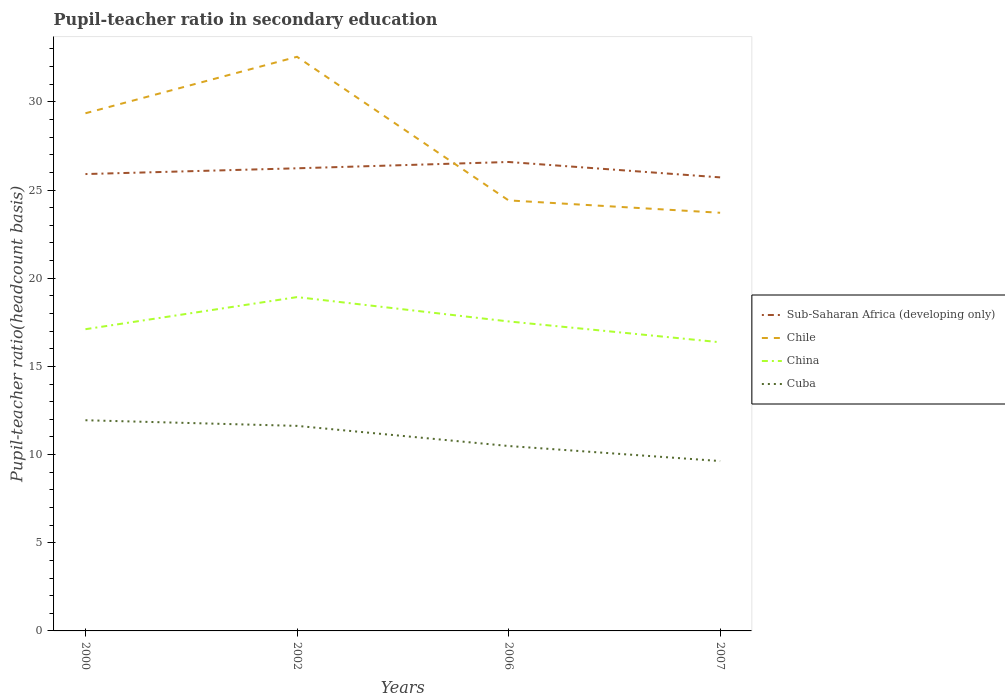Does the line corresponding to Sub-Saharan Africa (developing only) intersect with the line corresponding to China?
Your answer should be very brief. No. Across all years, what is the maximum pupil-teacher ratio in secondary education in China?
Keep it short and to the point. 16.37. In which year was the pupil-teacher ratio in secondary education in Sub-Saharan Africa (developing only) maximum?
Offer a terse response. 2007. What is the total pupil-teacher ratio in secondary education in Sub-Saharan Africa (developing only) in the graph?
Make the answer very short. -0.36. What is the difference between the highest and the second highest pupil-teacher ratio in secondary education in China?
Make the answer very short. 2.56. What is the difference between the highest and the lowest pupil-teacher ratio in secondary education in Chile?
Your answer should be compact. 2. Is the pupil-teacher ratio in secondary education in Chile strictly greater than the pupil-teacher ratio in secondary education in Sub-Saharan Africa (developing only) over the years?
Provide a short and direct response. No. Where does the legend appear in the graph?
Keep it short and to the point. Center right. How many legend labels are there?
Your response must be concise. 4. How are the legend labels stacked?
Your answer should be compact. Vertical. What is the title of the graph?
Make the answer very short. Pupil-teacher ratio in secondary education. Does "Mauritania" appear as one of the legend labels in the graph?
Offer a terse response. No. What is the label or title of the X-axis?
Your answer should be compact. Years. What is the label or title of the Y-axis?
Your response must be concise. Pupil-teacher ratio(headcount basis). What is the Pupil-teacher ratio(headcount basis) in Sub-Saharan Africa (developing only) in 2000?
Make the answer very short. 25.91. What is the Pupil-teacher ratio(headcount basis) of Chile in 2000?
Your answer should be compact. 29.35. What is the Pupil-teacher ratio(headcount basis) of China in 2000?
Offer a terse response. 17.11. What is the Pupil-teacher ratio(headcount basis) of Cuba in 2000?
Your answer should be compact. 11.95. What is the Pupil-teacher ratio(headcount basis) in Sub-Saharan Africa (developing only) in 2002?
Provide a succinct answer. 26.23. What is the Pupil-teacher ratio(headcount basis) of Chile in 2002?
Ensure brevity in your answer.  32.56. What is the Pupil-teacher ratio(headcount basis) of China in 2002?
Keep it short and to the point. 18.93. What is the Pupil-teacher ratio(headcount basis) in Cuba in 2002?
Keep it short and to the point. 11.63. What is the Pupil-teacher ratio(headcount basis) in Sub-Saharan Africa (developing only) in 2006?
Offer a terse response. 26.59. What is the Pupil-teacher ratio(headcount basis) in Chile in 2006?
Provide a short and direct response. 24.41. What is the Pupil-teacher ratio(headcount basis) of China in 2006?
Provide a succinct answer. 17.55. What is the Pupil-teacher ratio(headcount basis) of Cuba in 2006?
Provide a succinct answer. 10.49. What is the Pupil-teacher ratio(headcount basis) of Sub-Saharan Africa (developing only) in 2007?
Provide a short and direct response. 25.72. What is the Pupil-teacher ratio(headcount basis) in Chile in 2007?
Your answer should be compact. 23.71. What is the Pupil-teacher ratio(headcount basis) of China in 2007?
Keep it short and to the point. 16.37. What is the Pupil-teacher ratio(headcount basis) of Cuba in 2007?
Keep it short and to the point. 9.63. Across all years, what is the maximum Pupil-teacher ratio(headcount basis) of Sub-Saharan Africa (developing only)?
Keep it short and to the point. 26.59. Across all years, what is the maximum Pupil-teacher ratio(headcount basis) in Chile?
Provide a short and direct response. 32.56. Across all years, what is the maximum Pupil-teacher ratio(headcount basis) of China?
Give a very brief answer. 18.93. Across all years, what is the maximum Pupil-teacher ratio(headcount basis) of Cuba?
Your answer should be very brief. 11.95. Across all years, what is the minimum Pupil-teacher ratio(headcount basis) in Sub-Saharan Africa (developing only)?
Your answer should be very brief. 25.72. Across all years, what is the minimum Pupil-teacher ratio(headcount basis) of Chile?
Provide a short and direct response. 23.71. Across all years, what is the minimum Pupil-teacher ratio(headcount basis) in China?
Provide a succinct answer. 16.37. Across all years, what is the minimum Pupil-teacher ratio(headcount basis) in Cuba?
Provide a short and direct response. 9.63. What is the total Pupil-teacher ratio(headcount basis) in Sub-Saharan Africa (developing only) in the graph?
Your response must be concise. 104.45. What is the total Pupil-teacher ratio(headcount basis) of Chile in the graph?
Offer a very short reply. 110.03. What is the total Pupil-teacher ratio(headcount basis) in China in the graph?
Provide a short and direct response. 69.96. What is the total Pupil-teacher ratio(headcount basis) in Cuba in the graph?
Provide a succinct answer. 43.69. What is the difference between the Pupil-teacher ratio(headcount basis) of Sub-Saharan Africa (developing only) in 2000 and that in 2002?
Offer a very short reply. -0.33. What is the difference between the Pupil-teacher ratio(headcount basis) in Chile in 2000 and that in 2002?
Make the answer very short. -3.2. What is the difference between the Pupil-teacher ratio(headcount basis) in China in 2000 and that in 2002?
Your answer should be compact. -1.82. What is the difference between the Pupil-teacher ratio(headcount basis) of Cuba in 2000 and that in 2002?
Offer a very short reply. 0.32. What is the difference between the Pupil-teacher ratio(headcount basis) in Sub-Saharan Africa (developing only) in 2000 and that in 2006?
Your answer should be very brief. -0.68. What is the difference between the Pupil-teacher ratio(headcount basis) of Chile in 2000 and that in 2006?
Ensure brevity in your answer.  4.94. What is the difference between the Pupil-teacher ratio(headcount basis) of China in 2000 and that in 2006?
Make the answer very short. -0.44. What is the difference between the Pupil-teacher ratio(headcount basis) of Cuba in 2000 and that in 2006?
Provide a succinct answer. 1.46. What is the difference between the Pupil-teacher ratio(headcount basis) of Sub-Saharan Africa (developing only) in 2000 and that in 2007?
Provide a short and direct response. 0.19. What is the difference between the Pupil-teacher ratio(headcount basis) of Chile in 2000 and that in 2007?
Your answer should be compact. 5.64. What is the difference between the Pupil-teacher ratio(headcount basis) of China in 2000 and that in 2007?
Your response must be concise. 0.74. What is the difference between the Pupil-teacher ratio(headcount basis) in Cuba in 2000 and that in 2007?
Provide a succinct answer. 2.31. What is the difference between the Pupil-teacher ratio(headcount basis) in Sub-Saharan Africa (developing only) in 2002 and that in 2006?
Keep it short and to the point. -0.36. What is the difference between the Pupil-teacher ratio(headcount basis) of Chile in 2002 and that in 2006?
Provide a short and direct response. 8.14. What is the difference between the Pupil-teacher ratio(headcount basis) in China in 2002 and that in 2006?
Ensure brevity in your answer.  1.38. What is the difference between the Pupil-teacher ratio(headcount basis) in Cuba in 2002 and that in 2006?
Ensure brevity in your answer.  1.14. What is the difference between the Pupil-teacher ratio(headcount basis) in Sub-Saharan Africa (developing only) in 2002 and that in 2007?
Provide a short and direct response. 0.51. What is the difference between the Pupil-teacher ratio(headcount basis) of Chile in 2002 and that in 2007?
Make the answer very short. 8.84. What is the difference between the Pupil-teacher ratio(headcount basis) in China in 2002 and that in 2007?
Provide a short and direct response. 2.56. What is the difference between the Pupil-teacher ratio(headcount basis) in Cuba in 2002 and that in 2007?
Your answer should be compact. 1.99. What is the difference between the Pupil-teacher ratio(headcount basis) of Sub-Saharan Africa (developing only) in 2006 and that in 2007?
Ensure brevity in your answer.  0.87. What is the difference between the Pupil-teacher ratio(headcount basis) in Chile in 2006 and that in 2007?
Make the answer very short. 0.7. What is the difference between the Pupil-teacher ratio(headcount basis) in China in 2006 and that in 2007?
Your answer should be very brief. 1.18. What is the difference between the Pupil-teacher ratio(headcount basis) of Cuba in 2006 and that in 2007?
Your answer should be very brief. 0.85. What is the difference between the Pupil-teacher ratio(headcount basis) of Sub-Saharan Africa (developing only) in 2000 and the Pupil-teacher ratio(headcount basis) of Chile in 2002?
Give a very brief answer. -6.65. What is the difference between the Pupil-teacher ratio(headcount basis) in Sub-Saharan Africa (developing only) in 2000 and the Pupil-teacher ratio(headcount basis) in China in 2002?
Your answer should be very brief. 6.98. What is the difference between the Pupil-teacher ratio(headcount basis) in Sub-Saharan Africa (developing only) in 2000 and the Pupil-teacher ratio(headcount basis) in Cuba in 2002?
Give a very brief answer. 14.28. What is the difference between the Pupil-teacher ratio(headcount basis) in Chile in 2000 and the Pupil-teacher ratio(headcount basis) in China in 2002?
Your answer should be very brief. 10.42. What is the difference between the Pupil-teacher ratio(headcount basis) of Chile in 2000 and the Pupil-teacher ratio(headcount basis) of Cuba in 2002?
Keep it short and to the point. 17.73. What is the difference between the Pupil-teacher ratio(headcount basis) of China in 2000 and the Pupil-teacher ratio(headcount basis) of Cuba in 2002?
Your answer should be compact. 5.48. What is the difference between the Pupil-teacher ratio(headcount basis) in Sub-Saharan Africa (developing only) in 2000 and the Pupil-teacher ratio(headcount basis) in Chile in 2006?
Offer a terse response. 1.49. What is the difference between the Pupil-teacher ratio(headcount basis) of Sub-Saharan Africa (developing only) in 2000 and the Pupil-teacher ratio(headcount basis) of China in 2006?
Provide a succinct answer. 8.36. What is the difference between the Pupil-teacher ratio(headcount basis) in Sub-Saharan Africa (developing only) in 2000 and the Pupil-teacher ratio(headcount basis) in Cuba in 2006?
Your answer should be very brief. 15.42. What is the difference between the Pupil-teacher ratio(headcount basis) of Chile in 2000 and the Pupil-teacher ratio(headcount basis) of China in 2006?
Keep it short and to the point. 11.8. What is the difference between the Pupil-teacher ratio(headcount basis) in Chile in 2000 and the Pupil-teacher ratio(headcount basis) in Cuba in 2006?
Offer a terse response. 18.87. What is the difference between the Pupil-teacher ratio(headcount basis) of China in 2000 and the Pupil-teacher ratio(headcount basis) of Cuba in 2006?
Offer a very short reply. 6.62. What is the difference between the Pupil-teacher ratio(headcount basis) in Sub-Saharan Africa (developing only) in 2000 and the Pupil-teacher ratio(headcount basis) in Chile in 2007?
Offer a terse response. 2.19. What is the difference between the Pupil-teacher ratio(headcount basis) of Sub-Saharan Africa (developing only) in 2000 and the Pupil-teacher ratio(headcount basis) of China in 2007?
Your answer should be compact. 9.54. What is the difference between the Pupil-teacher ratio(headcount basis) in Sub-Saharan Africa (developing only) in 2000 and the Pupil-teacher ratio(headcount basis) in Cuba in 2007?
Offer a very short reply. 16.27. What is the difference between the Pupil-teacher ratio(headcount basis) in Chile in 2000 and the Pupil-teacher ratio(headcount basis) in China in 2007?
Offer a very short reply. 12.98. What is the difference between the Pupil-teacher ratio(headcount basis) in Chile in 2000 and the Pupil-teacher ratio(headcount basis) in Cuba in 2007?
Give a very brief answer. 19.72. What is the difference between the Pupil-teacher ratio(headcount basis) in China in 2000 and the Pupil-teacher ratio(headcount basis) in Cuba in 2007?
Provide a short and direct response. 7.48. What is the difference between the Pupil-teacher ratio(headcount basis) in Sub-Saharan Africa (developing only) in 2002 and the Pupil-teacher ratio(headcount basis) in Chile in 2006?
Make the answer very short. 1.82. What is the difference between the Pupil-teacher ratio(headcount basis) in Sub-Saharan Africa (developing only) in 2002 and the Pupil-teacher ratio(headcount basis) in China in 2006?
Ensure brevity in your answer.  8.68. What is the difference between the Pupil-teacher ratio(headcount basis) of Sub-Saharan Africa (developing only) in 2002 and the Pupil-teacher ratio(headcount basis) of Cuba in 2006?
Provide a succinct answer. 15.75. What is the difference between the Pupil-teacher ratio(headcount basis) in Chile in 2002 and the Pupil-teacher ratio(headcount basis) in China in 2006?
Your answer should be compact. 15.01. What is the difference between the Pupil-teacher ratio(headcount basis) in Chile in 2002 and the Pupil-teacher ratio(headcount basis) in Cuba in 2006?
Keep it short and to the point. 22.07. What is the difference between the Pupil-teacher ratio(headcount basis) in China in 2002 and the Pupil-teacher ratio(headcount basis) in Cuba in 2006?
Offer a terse response. 8.44. What is the difference between the Pupil-teacher ratio(headcount basis) in Sub-Saharan Africa (developing only) in 2002 and the Pupil-teacher ratio(headcount basis) in Chile in 2007?
Provide a succinct answer. 2.52. What is the difference between the Pupil-teacher ratio(headcount basis) of Sub-Saharan Africa (developing only) in 2002 and the Pupil-teacher ratio(headcount basis) of China in 2007?
Keep it short and to the point. 9.86. What is the difference between the Pupil-teacher ratio(headcount basis) in Chile in 2002 and the Pupil-teacher ratio(headcount basis) in China in 2007?
Your answer should be compact. 16.19. What is the difference between the Pupil-teacher ratio(headcount basis) of Chile in 2002 and the Pupil-teacher ratio(headcount basis) of Cuba in 2007?
Provide a short and direct response. 22.92. What is the difference between the Pupil-teacher ratio(headcount basis) in China in 2002 and the Pupil-teacher ratio(headcount basis) in Cuba in 2007?
Keep it short and to the point. 9.3. What is the difference between the Pupil-teacher ratio(headcount basis) of Sub-Saharan Africa (developing only) in 2006 and the Pupil-teacher ratio(headcount basis) of Chile in 2007?
Provide a short and direct response. 2.88. What is the difference between the Pupil-teacher ratio(headcount basis) in Sub-Saharan Africa (developing only) in 2006 and the Pupil-teacher ratio(headcount basis) in China in 2007?
Provide a succinct answer. 10.22. What is the difference between the Pupil-teacher ratio(headcount basis) in Sub-Saharan Africa (developing only) in 2006 and the Pupil-teacher ratio(headcount basis) in Cuba in 2007?
Make the answer very short. 16.96. What is the difference between the Pupil-teacher ratio(headcount basis) in Chile in 2006 and the Pupil-teacher ratio(headcount basis) in China in 2007?
Your answer should be very brief. 8.04. What is the difference between the Pupil-teacher ratio(headcount basis) in Chile in 2006 and the Pupil-teacher ratio(headcount basis) in Cuba in 2007?
Offer a terse response. 14.78. What is the difference between the Pupil-teacher ratio(headcount basis) in China in 2006 and the Pupil-teacher ratio(headcount basis) in Cuba in 2007?
Make the answer very short. 7.92. What is the average Pupil-teacher ratio(headcount basis) of Sub-Saharan Africa (developing only) per year?
Give a very brief answer. 26.11. What is the average Pupil-teacher ratio(headcount basis) in Chile per year?
Your answer should be compact. 27.51. What is the average Pupil-teacher ratio(headcount basis) in China per year?
Offer a very short reply. 17.49. What is the average Pupil-teacher ratio(headcount basis) of Cuba per year?
Give a very brief answer. 10.92. In the year 2000, what is the difference between the Pupil-teacher ratio(headcount basis) in Sub-Saharan Africa (developing only) and Pupil-teacher ratio(headcount basis) in Chile?
Provide a short and direct response. -3.45. In the year 2000, what is the difference between the Pupil-teacher ratio(headcount basis) of Sub-Saharan Africa (developing only) and Pupil-teacher ratio(headcount basis) of China?
Offer a very short reply. 8.8. In the year 2000, what is the difference between the Pupil-teacher ratio(headcount basis) of Sub-Saharan Africa (developing only) and Pupil-teacher ratio(headcount basis) of Cuba?
Provide a short and direct response. 13.96. In the year 2000, what is the difference between the Pupil-teacher ratio(headcount basis) in Chile and Pupil-teacher ratio(headcount basis) in China?
Offer a terse response. 12.24. In the year 2000, what is the difference between the Pupil-teacher ratio(headcount basis) of Chile and Pupil-teacher ratio(headcount basis) of Cuba?
Offer a very short reply. 17.41. In the year 2000, what is the difference between the Pupil-teacher ratio(headcount basis) in China and Pupil-teacher ratio(headcount basis) in Cuba?
Your answer should be very brief. 5.16. In the year 2002, what is the difference between the Pupil-teacher ratio(headcount basis) of Sub-Saharan Africa (developing only) and Pupil-teacher ratio(headcount basis) of Chile?
Your response must be concise. -6.32. In the year 2002, what is the difference between the Pupil-teacher ratio(headcount basis) of Sub-Saharan Africa (developing only) and Pupil-teacher ratio(headcount basis) of China?
Your answer should be compact. 7.3. In the year 2002, what is the difference between the Pupil-teacher ratio(headcount basis) of Sub-Saharan Africa (developing only) and Pupil-teacher ratio(headcount basis) of Cuba?
Ensure brevity in your answer.  14.61. In the year 2002, what is the difference between the Pupil-teacher ratio(headcount basis) in Chile and Pupil-teacher ratio(headcount basis) in China?
Ensure brevity in your answer.  13.63. In the year 2002, what is the difference between the Pupil-teacher ratio(headcount basis) in Chile and Pupil-teacher ratio(headcount basis) in Cuba?
Give a very brief answer. 20.93. In the year 2002, what is the difference between the Pupil-teacher ratio(headcount basis) of China and Pupil-teacher ratio(headcount basis) of Cuba?
Your answer should be compact. 7.3. In the year 2006, what is the difference between the Pupil-teacher ratio(headcount basis) in Sub-Saharan Africa (developing only) and Pupil-teacher ratio(headcount basis) in Chile?
Your answer should be very brief. 2.18. In the year 2006, what is the difference between the Pupil-teacher ratio(headcount basis) in Sub-Saharan Africa (developing only) and Pupil-teacher ratio(headcount basis) in China?
Your response must be concise. 9.04. In the year 2006, what is the difference between the Pupil-teacher ratio(headcount basis) in Sub-Saharan Africa (developing only) and Pupil-teacher ratio(headcount basis) in Cuba?
Make the answer very short. 16.1. In the year 2006, what is the difference between the Pupil-teacher ratio(headcount basis) in Chile and Pupil-teacher ratio(headcount basis) in China?
Provide a succinct answer. 6.86. In the year 2006, what is the difference between the Pupil-teacher ratio(headcount basis) of Chile and Pupil-teacher ratio(headcount basis) of Cuba?
Provide a short and direct response. 13.93. In the year 2006, what is the difference between the Pupil-teacher ratio(headcount basis) in China and Pupil-teacher ratio(headcount basis) in Cuba?
Make the answer very short. 7.06. In the year 2007, what is the difference between the Pupil-teacher ratio(headcount basis) in Sub-Saharan Africa (developing only) and Pupil-teacher ratio(headcount basis) in Chile?
Keep it short and to the point. 2.01. In the year 2007, what is the difference between the Pupil-teacher ratio(headcount basis) of Sub-Saharan Africa (developing only) and Pupil-teacher ratio(headcount basis) of China?
Give a very brief answer. 9.35. In the year 2007, what is the difference between the Pupil-teacher ratio(headcount basis) in Sub-Saharan Africa (developing only) and Pupil-teacher ratio(headcount basis) in Cuba?
Give a very brief answer. 16.09. In the year 2007, what is the difference between the Pupil-teacher ratio(headcount basis) of Chile and Pupil-teacher ratio(headcount basis) of China?
Ensure brevity in your answer.  7.34. In the year 2007, what is the difference between the Pupil-teacher ratio(headcount basis) in Chile and Pupil-teacher ratio(headcount basis) in Cuba?
Your response must be concise. 14.08. In the year 2007, what is the difference between the Pupil-teacher ratio(headcount basis) in China and Pupil-teacher ratio(headcount basis) in Cuba?
Ensure brevity in your answer.  6.74. What is the ratio of the Pupil-teacher ratio(headcount basis) of Sub-Saharan Africa (developing only) in 2000 to that in 2002?
Your answer should be compact. 0.99. What is the ratio of the Pupil-teacher ratio(headcount basis) of Chile in 2000 to that in 2002?
Offer a very short reply. 0.9. What is the ratio of the Pupil-teacher ratio(headcount basis) in China in 2000 to that in 2002?
Make the answer very short. 0.9. What is the ratio of the Pupil-teacher ratio(headcount basis) in Cuba in 2000 to that in 2002?
Your answer should be compact. 1.03. What is the ratio of the Pupil-teacher ratio(headcount basis) in Sub-Saharan Africa (developing only) in 2000 to that in 2006?
Provide a short and direct response. 0.97. What is the ratio of the Pupil-teacher ratio(headcount basis) in Chile in 2000 to that in 2006?
Your answer should be very brief. 1.2. What is the ratio of the Pupil-teacher ratio(headcount basis) in China in 2000 to that in 2006?
Offer a very short reply. 0.97. What is the ratio of the Pupil-teacher ratio(headcount basis) of Cuba in 2000 to that in 2006?
Keep it short and to the point. 1.14. What is the ratio of the Pupil-teacher ratio(headcount basis) in Sub-Saharan Africa (developing only) in 2000 to that in 2007?
Give a very brief answer. 1.01. What is the ratio of the Pupil-teacher ratio(headcount basis) in Chile in 2000 to that in 2007?
Provide a succinct answer. 1.24. What is the ratio of the Pupil-teacher ratio(headcount basis) in China in 2000 to that in 2007?
Offer a very short reply. 1.05. What is the ratio of the Pupil-teacher ratio(headcount basis) of Cuba in 2000 to that in 2007?
Provide a short and direct response. 1.24. What is the ratio of the Pupil-teacher ratio(headcount basis) in Sub-Saharan Africa (developing only) in 2002 to that in 2006?
Your answer should be compact. 0.99. What is the ratio of the Pupil-teacher ratio(headcount basis) in Chile in 2002 to that in 2006?
Keep it short and to the point. 1.33. What is the ratio of the Pupil-teacher ratio(headcount basis) in China in 2002 to that in 2006?
Keep it short and to the point. 1.08. What is the ratio of the Pupil-teacher ratio(headcount basis) of Cuba in 2002 to that in 2006?
Provide a succinct answer. 1.11. What is the ratio of the Pupil-teacher ratio(headcount basis) in Chile in 2002 to that in 2007?
Your answer should be very brief. 1.37. What is the ratio of the Pupil-teacher ratio(headcount basis) in China in 2002 to that in 2007?
Ensure brevity in your answer.  1.16. What is the ratio of the Pupil-teacher ratio(headcount basis) of Cuba in 2002 to that in 2007?
Ensure brevity in your answer.  1.21. What is the ratio of the Pupil-teacher ratio(headcount basis) of Sub-Saharan Africa (developing only) in 2006 to that in 2007?
Your response must be concise. 1.03. What is the ratio of the Pupil-teacher ratio(headcount basis) in Chile in 2006 to that in 2007?
Ensure brevity in your answer.  1.03. What is the ratio of the Pupil-teacher ratio(headcount basis) in China in 2006 to that in 2007?
Make the answer very short. 1.07. What is the ratio of the Pupil-teacher ratio(headcount basis) of Cuba in 2006 to that in 2007?
Provide a succinct answer. 1.09. What is the difference between the highest and the second highest Pupil-teacher ratio(headcount basis) in Sub-Saharan Africa (developing only)?
Provide a succinct answer. 0.36. What is the difference between the highest and the second highest Pupil-teacher ratio(headcount basis) in Chile?
Offer a terse response. 3.2. What is the difference between the highest and the second highest Pupil-teacher ratio(headcount basis) of China?
Provide a short and direct response. 1.38. What is the difference between the highest and the second highest Pupil-teacher ratio(headcount basis) in Cuba?
Your answer should be compact. 0.32. What is the difference between the highest and the lowest Pupil-teacher ratio(headcount basis) in Sub-Saharan Africa (developing only)?
Make the answer very short. 0.87. What is the difference between the highest and the lowest Pupil-teacher ratio(headcount basis) of Chile?
Make the answer very short. 8.84. What is the difference between the highest and the lowest Pupil-teacher ratio(headcount basis) in China?
Your response must be concise. 2.56. What is the difference between the highest and the lowest Pupil-teacher ratio(headcount basis) in Cuba?
Offer a very short reply. 2.31. 